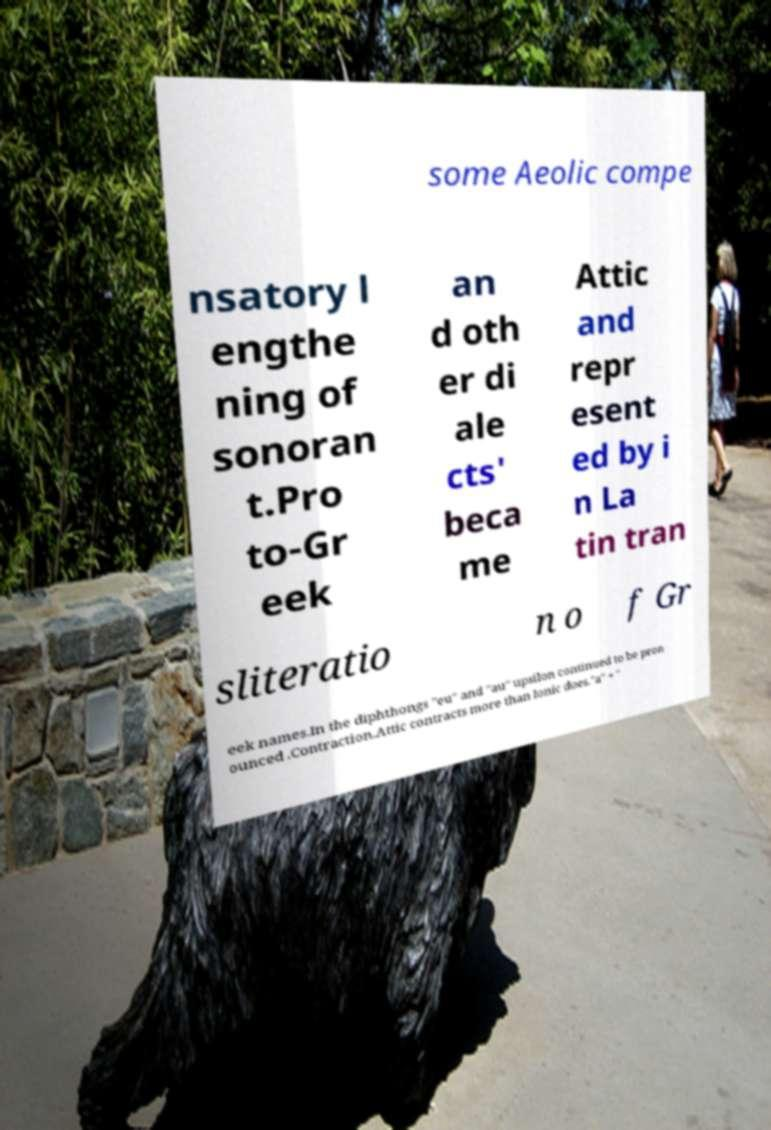Could you extract and type out the text from this image? some Aeolic compe nsatory l engthe ning of sonoran t.Pro to-Gr eek an d oth er di ale cts' beca me Attic and repr esent ed by i n La tin tran sliteratio n o f Gr eek names.In the diphthongs "eu" and "au" upsilon continued to be pron ounced .Contraction.Attic contracts more than Ionic does."a" + " 